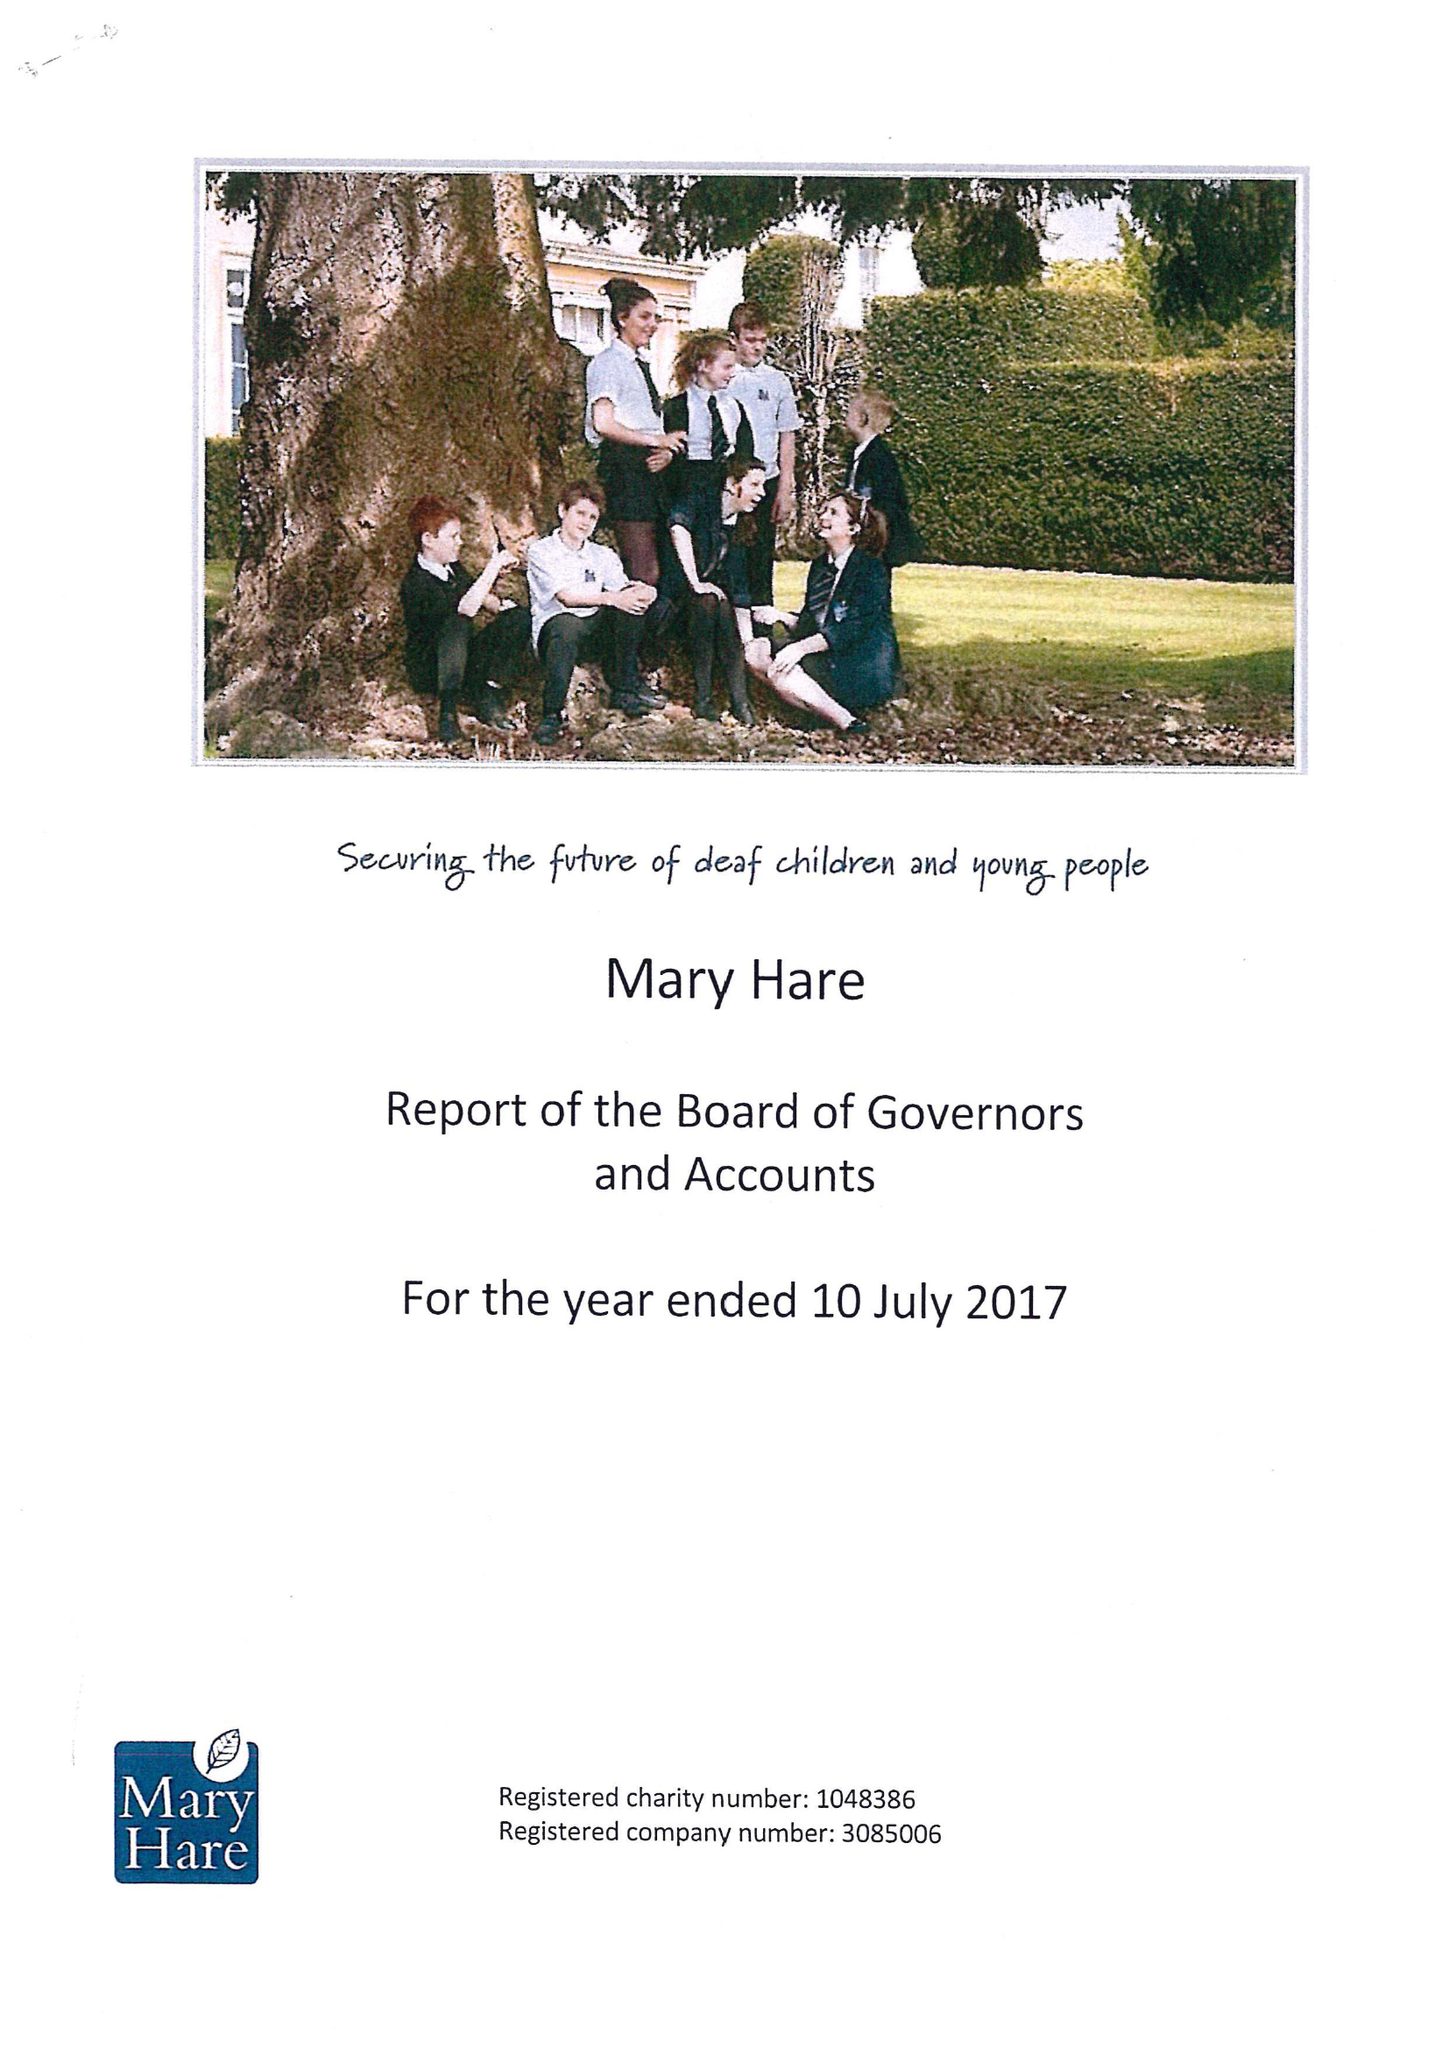What is the value for the spending_annually_in_british_pounds?
Answer the question using a single word or phrase. 11912000.00 